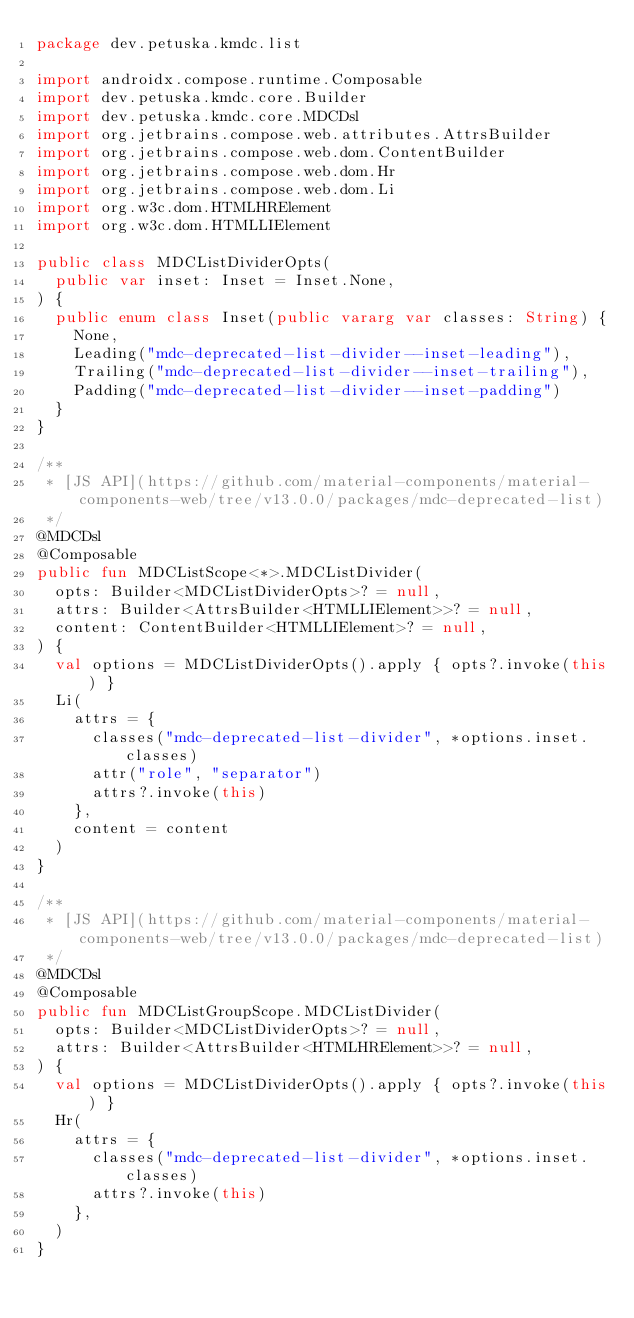Convert code to text. <code><loc_0><loc_0><loc_500><loc_500><_Kotlin_>package dev.petuska.kmdc.list

import androidx.compose.runtime.Composable
import dev.petuska.kmdc.core.Builder
import dev.petuska.kmdc.core.MDCDsl
import org.jetbrains.compose.web.attributes.AttrsBuilder
import org.jetbrains.compose.web.dom.ContentBuilder
import org.jetbrains.compose.web.dom.Hr
import org.jetbrains.compose.web.dom.Li
import org.w3c.dom.HTMLHRElement
import org.w3c.dom.HTMLLIElement

public class MDCListDividerOpts(
  public var inset: Inset = Inset.None,
) {
  public enum class Inset(public vararg var classes: String) {
    None,
    Leading("mdc-deprecated-list-divider--inset-leading"),
    Trailing("mdc-deprecated-list-divider--inset-trailing"),
    Padding("mdc-deprecated-list-divider--inset-padding")
  }
}

/**
 * [JS API](https://github.com/material-components/material-components-web/tree/v13.0.0/packages/mdc-deprecated-list)
 */
@MDCDsl
@Composable
public fun MDCListScope<*>.MDCListDivider(
  opts: Builder<MDCListDividerOpts>? = null,
  attrs: Builder<AttrsBuilder<HTMLLIElement>>? = null,
  content: ContentBuilder<HTMLLIElement>? = null,
) {
  val options = MDCListDividerOpts().apply { opts?.invoke(this) }
  Li(
    attrs = {
      classes("mdc-deprecated-list-divider", *options.inset.classes)
      attr("role", "separator")
      attrs?.invoke(this)
    },
    content = content
  )
}

/**
 * [JS API](https://github.com/material-components/material-components-web/tree/v13.0.0/packages/mdc-deprecated-list)
 */
@MDCDsl
@Composable
public fun MDCListGroupScope.MDCListDivider(
  opts: Builder<MDCListDividerOpts>? = null,
  attrs: Builder<AttrsBuilder<HTMLHRElement>>? = null,
) {
  val options = MDCListDividerOpts().apply { opts?.invoke(this) }
  Hr(
    attrs = {
      classes("mdc-deprecated-list-divider", *options.inset.classes)
      attrs?.invoke(this)
    },
  )
}
</code> 